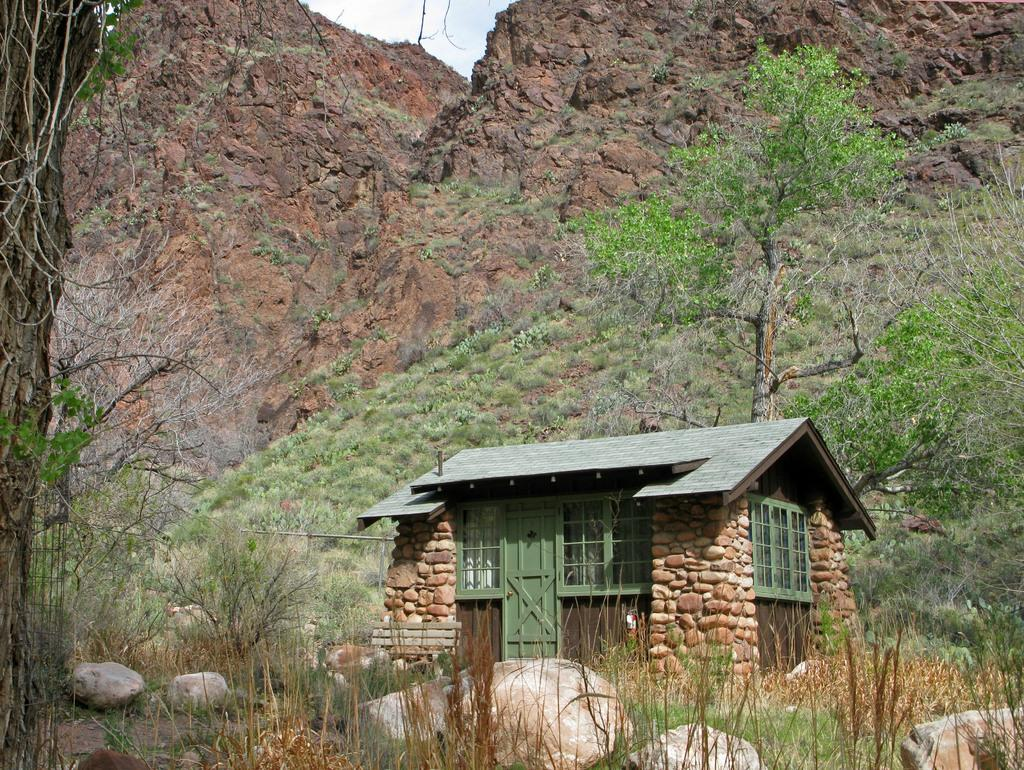What type of structure is in the picture? There is a house in the picture. What features can be seen on the house? The house has a door and windows. What can be seen in the background of the picture? There are trees, a rock, and the sky visible in the background of the picture. How does the wave transport the pipe in the image? There is no wave, transport, or pipe present in the image. 